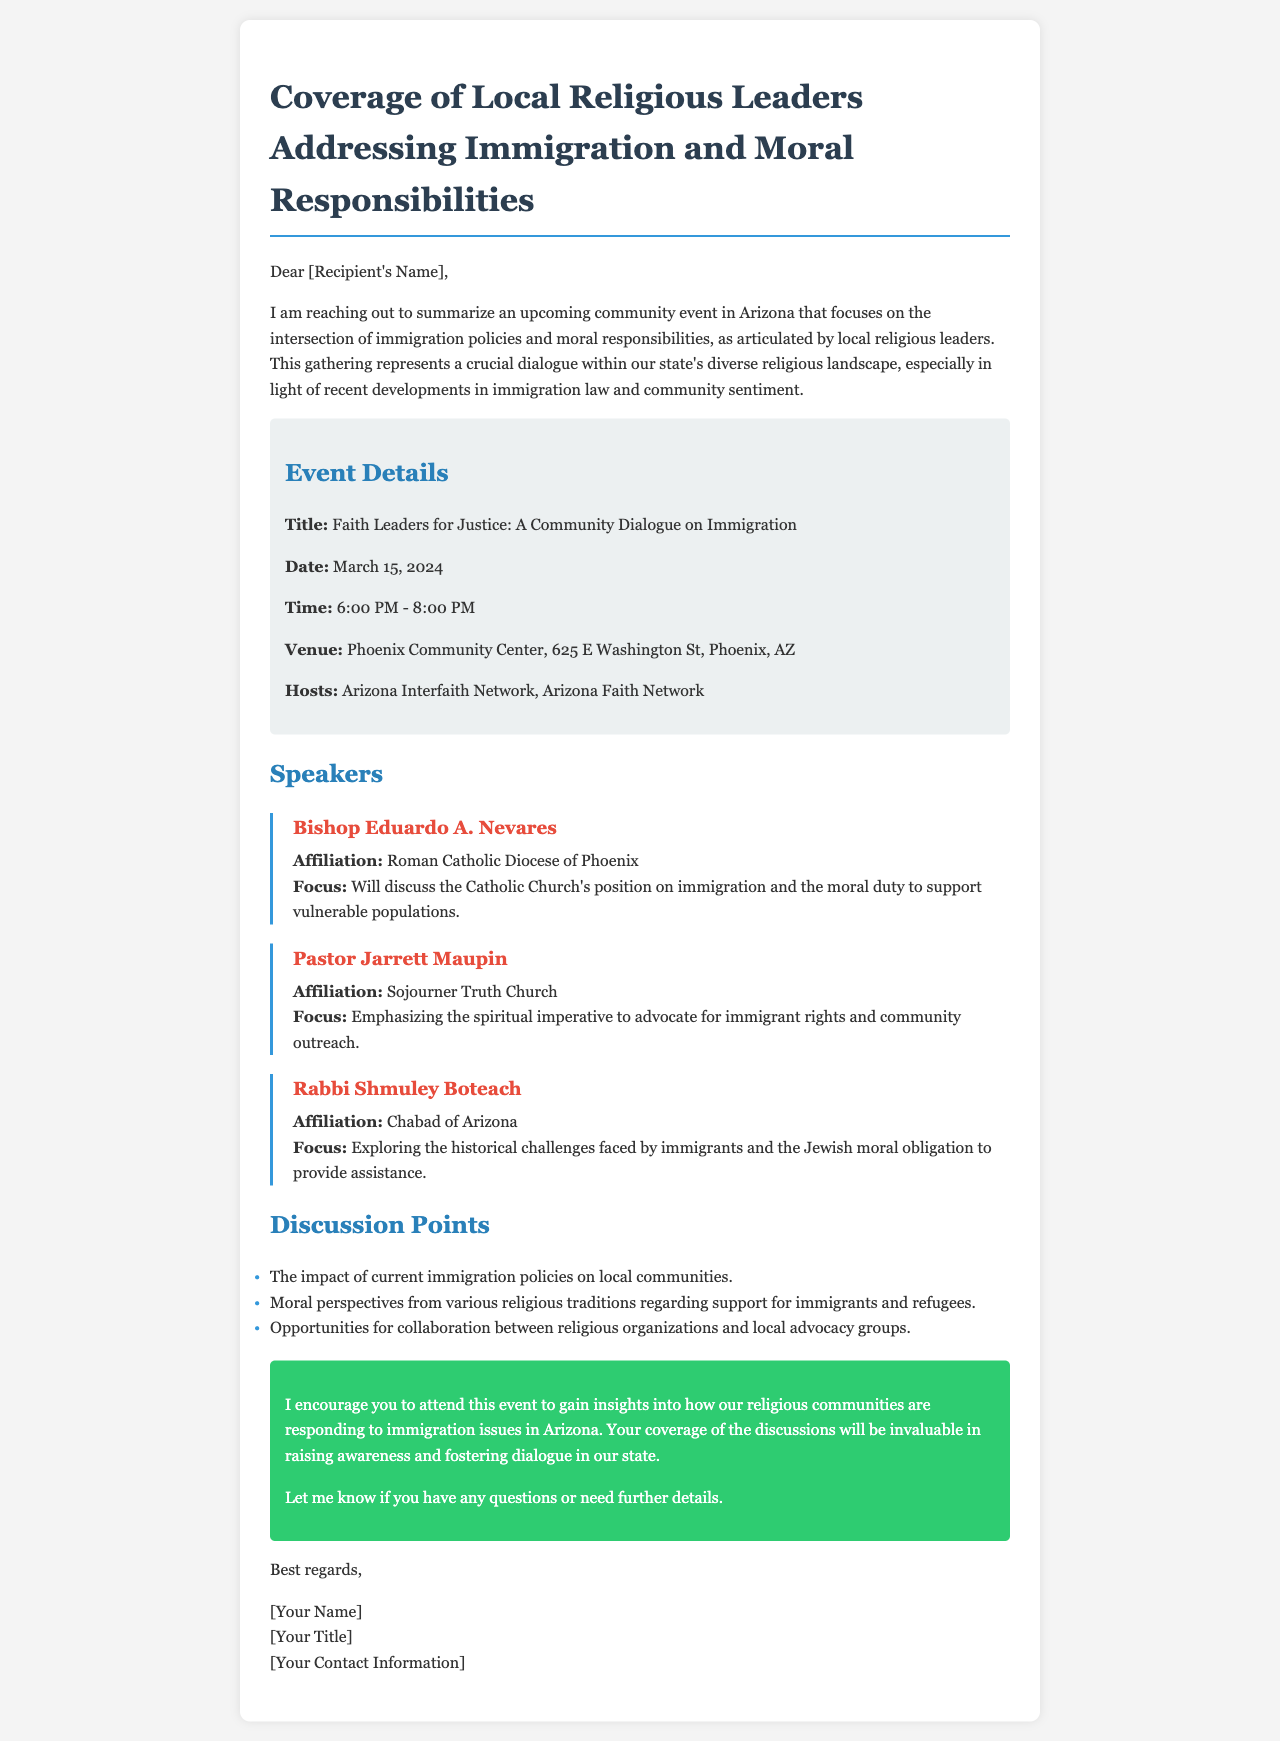What is the title of the event? The title of the event is stated clearly in the document under the event details section.
Answer: Faith Leaders for Justice: A Community Dialogue on Immigration What date is the event scheduled for? The date of the event is listed in the event details section of the document.
Answer: March 15, 2024 Where will the event take place? The venue is outlined in the event details section, providing the location for the event.
Answer: Phoenix Community Center, 625 E Washington St, Phoenix, AZ Who is hosting the event? The hosts of the event are mentioned in the event details section.
Answer: Arizona Interfaith Network, Arizona Faith Network Which speaker is affiliated with the Roman Catholic Diocese of Phoenix? The affiliation of each speaker is detailed in the speaker section, identifying their respective organizations.
Answer: Bishop Eduardo A. Nevares What is one of the discussion points mentioned in the document? The document lists specific topics that will be discussed during the event.
Answer: The impact of current immigration policies on local communities How long is the event scheduled to last? The time frame for the event is provided in the event details, indicating the duration of the gathering.
Answer: 2 hours What is the moral focus of Rabbi Shmuley Boteach's discussion? The focus for each speaker is presented, detailing the themes they will address during the event.
Answer: Exploring the historical challenges faced by immigrants and the Jewish moral obligation to provide assistance What is the purpose of the call to action in the document? The call to action outlines a specific request from the writer to encourage attendance and coverage of the event.
Answer: To gain insights into how our religious communities are responding to immigration issues in Arizona 